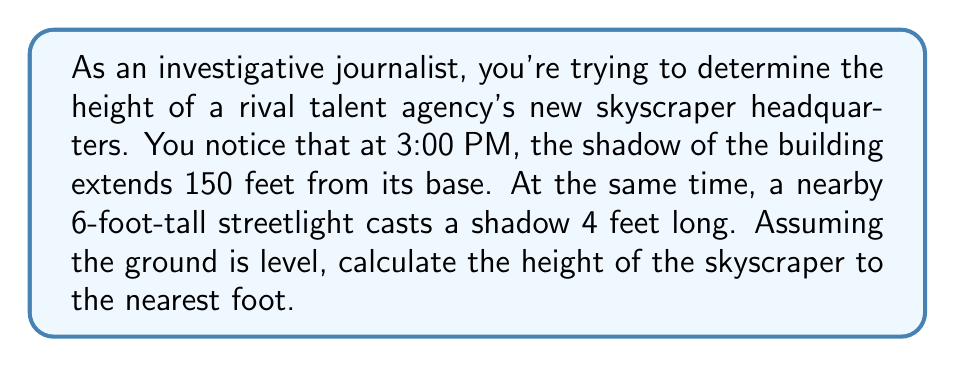What is the answer to this math problem? Let's approach this step-by-step using trigonometric ratios:

1) First, we need to find the angle of elevation of the sun. We can do this using the streetlight and its shadow.

2) For the streetlight:
   - Height = 6 feet
   - Shadow length = 4 feet
   
   We can use the tangent ratio:
   
   $$\tan(\theta) = \frac{\text{opposite}}{\text{adjacent}} = \frac{\text{height}}{\text{shadow length}}$$

3) Substituting our values:

   $$\tan(\theta) = \frac{6}{4} = 1.5$$

4) To find the angle, we use the inverse tangent (arctan):

   $$\theta = \arctan(1.5) \approx 56.31°$$

5) Now that we know the angle of elevation of the sun, we can use this to find the height of the skyscraper.

6) For the skyscraper:
   - Shadow length = 150 feet
   - Height = x (what we're solving for)

7) Using the tangent ratio again:

   $$\tan(56.31°) = \frac{x}{150}$$

8) Solving for x:

   $$x = 150 \cdot \tan(56.31°)$$

9) Calculate:

   $$x \approx 150 \cdot 1.5 = 225$$

Therefore, the height of the skyscraper is approximately 225 feet.

[asy]
import geometry;

size(200);

pair A = (0,0), B = (150,0), C = (0,225);
draw(A--B--C--A);
draw(A--(75,0), dashed);
draw((75,0)--(75,112.5), dashed);

label("150 ft", (75,-5), S);
label("225 ft", (-5,112.5), W);
label("56.31°", (5,5), NE);

draw((140,0)--(150,15));
draw((145,0)--(150,7.5));
[/asy]
Answer: The height of the skyscraper is approximately 225 feet. 